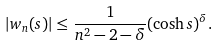<formula> <loc_0><loc_0><loc_500><loc_500>| w _ { n } ( s ) | \leq \frac { 1 } { n ^ { 2 } - 2 - \delta } ( \cosh s ) ^ { \delta } .</formula> 